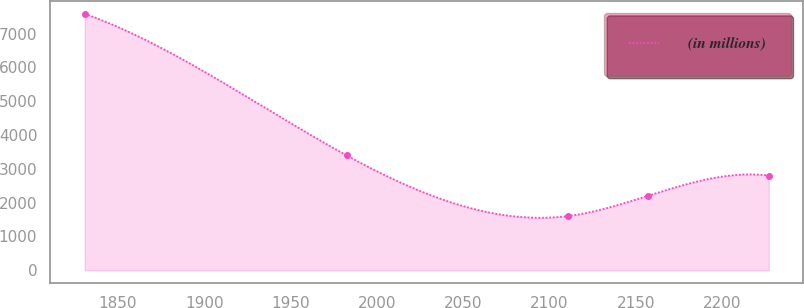Convert chart. <chart><loc_0><loc_0><loc_500><loc_500><line_chart><ecel><fcel>(in millions)<nl><fcel>1830.81<fcel>7584.67<nl><fcel>1982.47<fcel>3397.54<nl><fcel>2110.61<fcel>1603.06<nl><fcel>2156.94<fcel>2201.22<nl><fcel>2226.97<fcel>2799.38<nl></chart> 